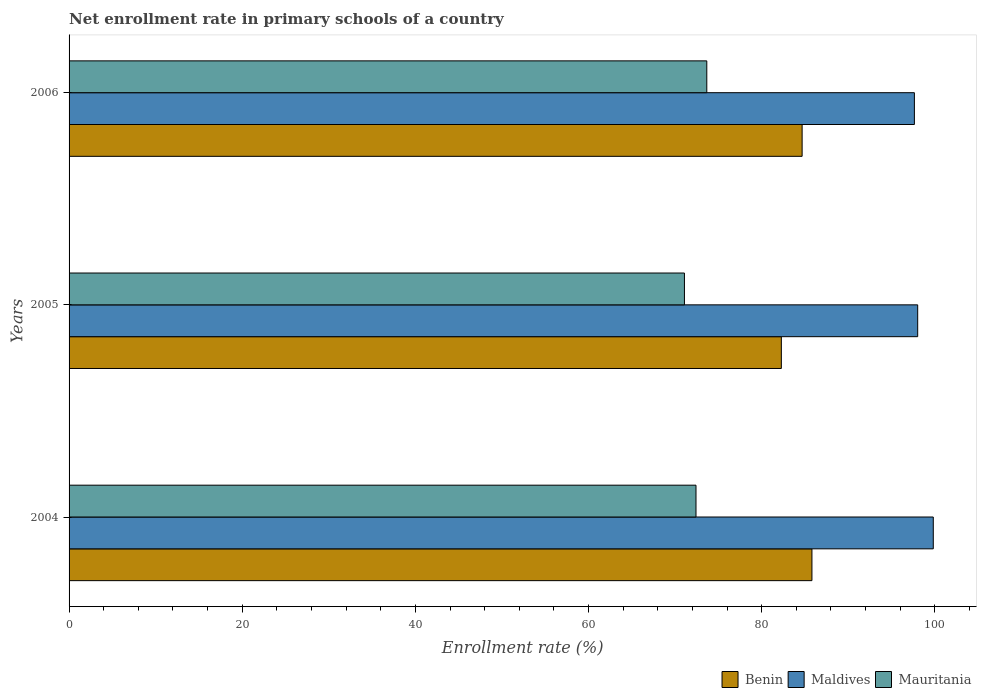Are the number of bars on each tick of the Y-axis equal?
Make the answer very short. Yes. How many bars are there on the 2nd tick from the top?
Your answer should be compact. 3. What is the enrollment rate in primary schools in Maldives in 2005?
Ensure brevity in your answer.  98.02. Across all years, what is the maximum enrollment rate in primary schools in Benin?
Ensure brevity in your answer.  85.81. Across all years, what is the minimum enrollment rate in primary schools in Mauritania?
Make the answer very short. 71.08. What is the total enrollment rate in primary schools in Mauritania in the graph?
Your answer should be very brief. 217.16. What is the difference between the enrollment rate in primary schools in Mauritania in 2005 and that in 2006?
Offer a very short reply. -2.58. What is the difference between the enrollment rate in primary schools in Benin in 2004 and the enrollment rate in primary schools in Maldives in 2006?
Your response must be concise. -11.83. What is the average enrollment rate in primary schools in Benin per year?
Offer a terse response. 84.25. In the year 2006, what is the difference between the enrollment rate in primary schools in Mauritania and enrollment rate in primary schools in Maldives?
Offer a very short reply. -23.98. In how many years, is the enrollment rate in primary schools in Mauritania greater than 28 %?
Provide a short and direct response. 3. What is the ratio of the enrollment rate in primary schools in Maldives in 2004 to that in 2006?
Keep it short and to the point. 1.02. Is the difference between the enrollment rate in primary schools in Mauritania in 2004 and 2005 greater than the difference between the enrollment rate in primary schools in Maldives in 2004 and 2005?
Keep it short and to the point. No. What is the difference between the highest and the second highest enrollment rate in primary schools in Maldives?
Provide a succinct answer. 1.8. What is the difference between the highest and the lowest enrollment rate in primary schools in Benin?
Ensure brevity in your answer.  3.53. In how many years, is the enrollment rate in primary schools in Maldives greater than the average enrollment rate in primary schools in Maldives taken over all years?
Make the answer very short. 1. What does the 1st bar from the top in 2004 represents?
Your answer should be compact. Mauritania. What does the 3rd bar from the bottom in 2005 represents?
Ensure brevity in your answer.  Mauritania. Is it the case that in every year, the sum of the enrollment rate in primary schools in Maldives and enrollment rate in primary schools in Mauritania is greater than the enrollment rate in primary schools in Benin?
Provide a succinct answer. Yes. How many bars are there?
Make the answer very short. 9. How many years are there in the graph?
Provide a succinct answer. 3. What is the difference between two consecutive major ticks on the X-axis?
Give a very brief answer. 20. Where does the legend appear in the graph?
Offer a terse response. Bottom right. What is the title of the graph?
Make the answer very short. Net enrollment rate in primary schools of a country. Does "St. Lucia" appear as one of the legend labels in the graph?
Your answer should be compact. No. What is the label or title of the X-axis?
Give a very brief answer. Enrollment rate (%). What is the label or title of the Y-axis?
Ensure brevity in your answer.  Years. What is the Enrollment rate (%) of Benin in 2004?
Offer a terse response. 85.81. What is the Enrollment rate (%) of Maldives in 2004?
Provide a succinct answer. 99.82. What is the Enrollment rate (%) in Mauritania in 2004?
Ensure brevity in your answer.  72.41. What is the Enrollment rate (%) in Benin in 2005?
Keep it short and to the point. 82.27. What is the Enrollment rate (%) of Maldives in 2005?
Offer a very short reply. 98.02. What is the Enrollment rate (%) in Mauritania in 2005?
Your answer should be very brief. 71.08. What is the Enrollment rate (%) in Benin in 2006?
Provide a short and direct response. 84.67. What is the Enrollment rate (%) in Maldives in 2006?
Keep it short and to the point. 97.64. What is the Enrollment rate (%) in Mauritania in 2006?
Make the answer very short. 73.66. Across all years, what is the maximum Enrollment rate (%) in Benin?
Give a very brief answer. 85.81. Across all years, what is the maximum Enrollment rate (%) in Maldives?
Keep it short and to the point. 99.82. Across all years, what is the maximum Enrollment rate (%) of Mauritania?
Offer a very short reply. 73.66. Across all years, what is the minimum Enrollment rate (%) in Benin?
Give a very brief answer. 82.27. Across all years, what is the minimum Enrollment rate (%) of Maldives?
Provide a succinct answer. 97.64. Across all years, what is the minimum Enrollment rate (%) of Mauritania?
Keep it short and to the point. 71.08. What is the total Enrollment rate (%) of Benin in the graph?
Your response must be concise. 252.75. What is the total Enrollment rate (%) in Maldives in the graph?
Provide a succinct answer. 295.48. What is the total Enrollment rate (%) in Mauritania in the graph?
Keep it short and to the point. 217.16. What is the difference between the Enrollment rate (%) in Benin in 2004 and that in 2005?
Your answer should be compact. 3.53. What is the difference between the Enrollment rate (%) in Maldives in 2004 and that in 2005?
Keep it short and to the point. 1.8. What is the difference between the Enrollment rate (%) in Mauritania in 2004 and that in 2005?
Make the answer very short. 1.33. What is the difference between the Enrollment rate (%) of Benin in 2004 and that in 2006?
Keep it short and to the point. 1.13. What is the difference between the Enrollment rate (%) in Maldives in 2004 and that in 2006?
Keep it short and to the point. 2.18. What is the difference between the Enrollment rate (%) in Mauritania in 2004 and that in 2006?
Offer a very short reply. -1.25. What is the difference between the Enrollment rate (%) in Benin in 2005 and that in 2006?
Keep it short and to the point. -2.4. What is the difference between the Enrollment rate (%) in Maldives in 2005 and that in 2006?
Provide a succinct answer. 0.38. What is the difference between the Enrollment rate (%) in Mauritania in 2005 and that in 2006?
Keep it short and to the point. -2.58. What is the difference between the Enrollment rate (%) of Benin in 2004 and the Enrollment rate (%) of Maldives in 2005?
Your answer should be compact. -12.22. What is the difference between the Enrollment rate (%) in Benin in 2004 and the Enrollment rate (%) in Mauritania in 2005?
Make the answer very short. 14.73. What is the difference between the Enrollment rate (%) in Maldives in 2004 and the Enrollment rate (%) in Mauritania in 2005?
Offer a very short reply. 28.74. What is the difference between the Enrollment rate (%) in Benin in 2004 and the Enrollment rate (%) in Maldives in 2006?
Provide a short and direct response. -11.83. What is the difference between the Enrollment rate (%) in Benin in 2004 and the Enrollment rate (%) in Mauritania in 2006?
Your answer should be compact. 12.14. What is the difference between the Enrollment rate (%) of Maldives in 2004 and the Enrollment rate (%) of Mauritania in 2006?
Give a very brief answer. 26.16. What is the difference between the Enrollment rate (%) in Benin in 2005 and the Enrollment rate (%) in Maldives in 2006?
Provide a short and direct response. -15.37. What is the difference between the Enrollment rate (%) in Benin in 2005 and the Enrollment rate (%) in Mauritania in 2006?
Offer a very short reply. 8.61. What is the difference between the Enrollment rate (%) in Maldives in 2005 and the Enrollment rate (%) in Mauritania in 2006?
Offer a terse response. 24.36. What is the average Enrollment rate (%) of Benin per year?
Offer a very short reply. 84.25. What is the average Enrollment rate (%) of Maldives per year?
Offer a very short reply. 98.49. What is the average Enrollment rate (%) in Mauritania per year?
Make the answer very short. 72.39. In the year 2004, what is the difference between the Enrollment rate (%) of Benin and Enrollment rate (%) of Maldives?
Keep it short and to the point. -14.02. In the year 2004, what is the difference between the Enrollment rate (%) in Benin and Enrollment rate (%) in Mauritania?
Your answer should be compact. 13.39. In the year 2004, what is the difference between the Enrollment rate (%) in Maldives and Enrollment rate (%) in Mauritania?
Your answer should be compact. 27.41. In the year 2005, what is the difference between the Enrollment rate (%) in Benin and Enrollment rate (%) in Maldives?
Offer a very short reply. -15.75. In the year 2005, what is the difference between the Enrollment rate (%) of Benin and Enrollment rate (%) of Mauritania?
Offer a very short reply. 11.19. In the year 2005, what is the difference between the Enrollment rate (%) of Maldives and Enrollment rate (%) of Mauritania?
Your answer should be compact. 26.94. In the year 2006, what is the difference between the Enrollment rate (%) of Benin and Enrollment rate (%) of Maldives?
Make the answer very short. -12.97. In the year 2006, what is the difference between the Enrollment rate (%) in Benin and Enrollment rate (%) in Mauritania?
Give a very brief answer. 11.01. In the year 2006, what is the difference between the Enrollment rate (%) of Maldives and Enrollment rate (%) of Mauritania?
Provide a short and direct response. 23.98. What is the ratio of the Enrollment rate (%) in Benin in 2004 to that in 2005?
Make the answer very short. 1.04. What is the ratio of the Enrollment rate (%) in Maldives in 2004 to that in 2005?
Your answer should be very brief. 1.02. What is the ratio of the Enrollment rate (%) in Mauritania in 2004 to that in 2005?
Your answer should be compact. 1.02. What is the ratio of the Enrollment rate (%) in Benin in 2004 to that in 2006?
Your response must be concise. 1.01. What is the ratio of the Enrollment rate (%) in Maldives in 2004 to that in 2006?
Your answer should be very brief. 1.02. What is the ratio of the Enrollment rate (%) in Mauritania in 2004 to that in 2006?
Your answer should be compact. 0.98. What is the ratio of the Enrollment rate (%) of Benin in 2005 to that in 2006?
Offer a terse response. 0.97. What is the ratio of the Enrollment rate (%) in Maldives in 2005 to that in 2006?
Your response must be concise. 1. What is the ratio of the Enrollment rate (%) in Mauritania in 2005 to that in 2006?
Provide a succinct answer. 0.96. What is the difference between the highest and the second highest Enrollment rate (%) in Benin?
Give a very brief answer. 1.13. What is the difference between the highest and the second highest Enrollment rate (%) in Maldives?
Ensure brevity in your answer.  1.8. What is the difference between the highest and the second highest Enrollment rate (%) in Mauritania?
Provide a succinct answer. 1.25. What is the difference between the highest and the lowest Enrollment rate (%) of Benin?
Keep it short and to the point. 3.53. What is the difference between the highest and the lowest Enrollment rate (%) of Maldives?
Your answer should be very brief. 2.18. What is the difference between the highest and the lowest Enrollment rate (%) in Mauritania?
Keep it short and to the point. 2.58. 